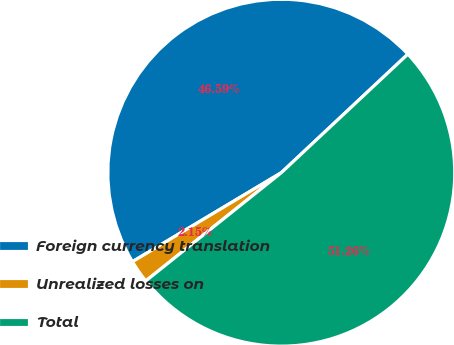Convert chart. <chart><loc_0><loc_0><loc_500><loc_500><pie_chart><fcel>Foreign currency translation<fcel>Unrealized losses on<fcel>Total<nl><fcel>46.59%<fcel>2.15%<fcel>51.25%<nl></chart> 